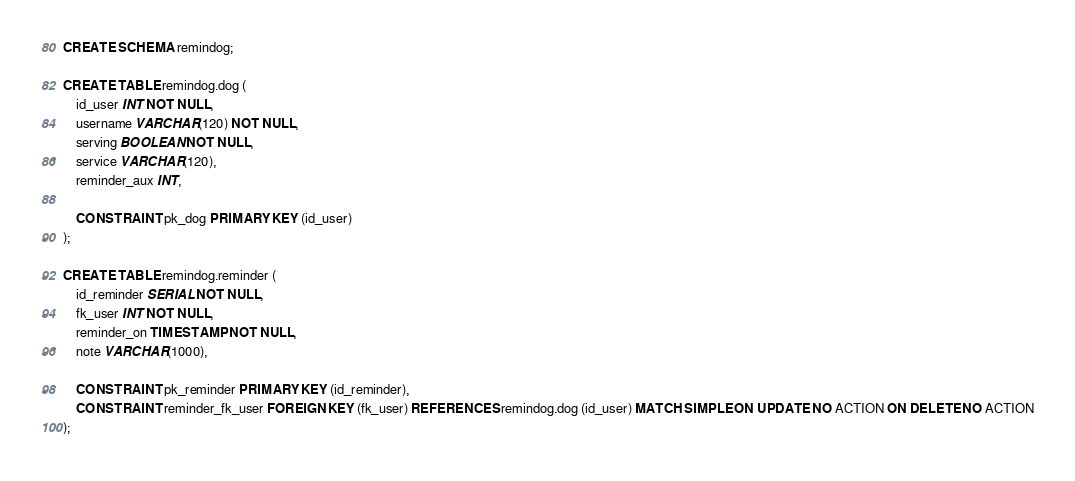Convert code to text. <code><loc_0><loc_0><loc_500><loc_500><_SQL_>CREATE SCHEMA remindog;

CREATE TABLE remindog.dog (
    id_user INT NOT NULL,
    username VARCHAR(120) NOT NULL,
    serving BOOLEAN NOT NULL,
    service VARCHAR(120),
    reminder_aux INT,

    CONSTRAINT pk_dog PRIMARY KEY (id_user)
);

CREATE TABLE remindog.reminder (
    id_reminder SERIAL NOT NULL,
    fk_user INT NOT NULL,
    reminder_on TIMESTAMP NOT NULL,
    note VARCHAR(1000),

    CONSTRAINT pk_reminder PRIMARY KEY (id_reminder),
    CONSTRAINT reminder_fk_user FOREIGN KEY (fk_user) REFERENCES remindog.dog (id_user) MATCH SIMPLE ON UPDATE NO ACTION ON DELETE NO ACTION
);</code> 